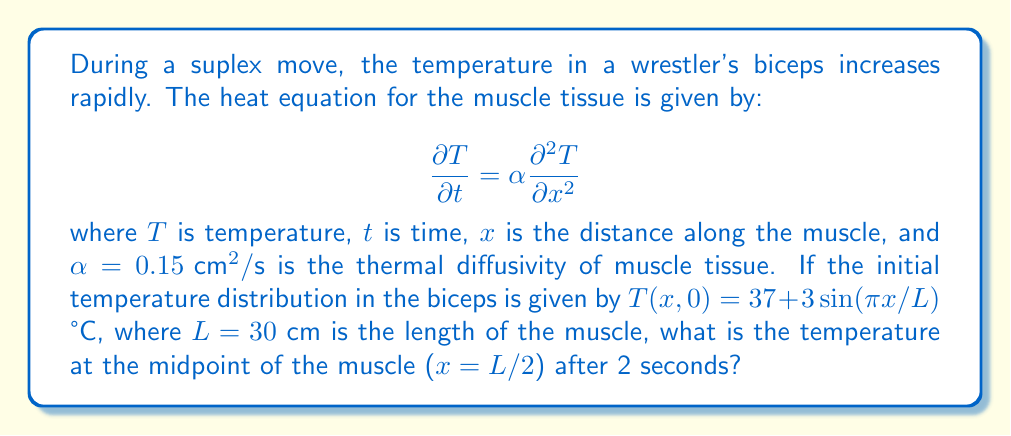Solve this math problem. To solve this problem, we need to use the separation of variables method for the heat equation.

1) First, we assume a solution of the form $T(x,t) = X(x)Y(t)$.

2) Substituting this into the heat equation, we get:
   $$X(x)Y'(t) = \alpha X''(x)Y(t)$$

3) Dividing both sides by $\alpha X(x)Y(t)$, we obtain:
   $$\frac{Y'(t)}{\alpha Y(t)} = \frac{X''(x)}{X(x)} = -\lambda$$

   where $-\lambda$ is a constant.

4) This gives us two ordinary differential equations:
   $$Y'(t) + \alpha \lambda Y(t) = 0$$
   $$X''(x) + \lambda X(x) = 0$$

5) The general solution for $X(x)$ that satisfies the boundary conditions is:
   $$X(x) = A\sin(\sqrt{\lambda}x)$$

   where $\sqrt{\lambda} = n\pi/L$ for $n = 1, 2, 3, ...$

6) The solution for $Y(t)$ is:
   $$Y(t) = Be^{-\alpha \lambda t}$$

7) Therefore, the general solution is:
   $$T(x,t) = \sum_{n=1}^{\infty} A_n \sin(\frac{n\pi x}{L})e^{-\alpha (\frac{n\pi}{L})^2 t}$$

8) From the initial condition, we can see that only the $n=1$ term is present:
   $$T(x,0) = 37 + 3\sin(\frac{\pi x}{L})$$

9) Therefore, our solution simplifies to:
   $$T(x,t) = 37 + 3\sin(\frac{\pi x}{L})e^{-\alpha (\frac{\pi}{L})^2 t}$$

10) At the midpoint of the muscle ($x = L/2$) after 2 seconds:
    $$T(L/2, 2) = 37 + 3\sin(\frac{\pi}{2})e^{-0.15 (\frac{\pi}{30})^2 2}$$

11) Calculating:
    $$T(L/2, 2) = 37 + 3 \cdot 1 \cdot e^{-0.0066} \approx 39.98 \text{ °C}$$
Answer: 39.98 °C 